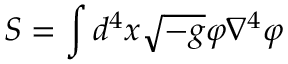Convert formula to latex. <formula><loc_0><loc_0><loc_500><loc_500>S = \int { d ^ { 4 } x } \sqrt { - g } \varphi \nabla ^ { 4 } \varphi</formula> 